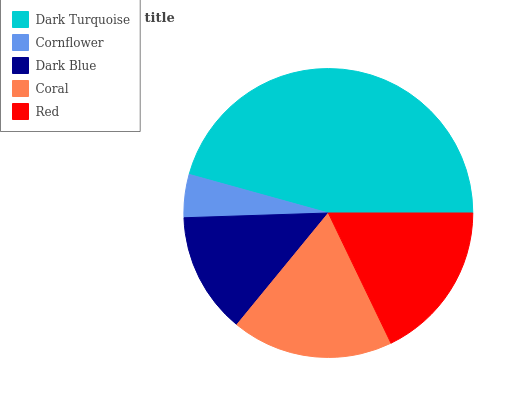Is Cornflower the minimum?
Answer yes or no. Yes. Is Dark Turquoise the maximum?
Answer yes or no. Yes. Is Dark Blue the minimum?
Answer yes or no. No. Is Dark Blue the maximum?
Answer yes or no. No. Is Dark Blue greater than Cornflower?
Answer yes or no. Yes. Is Cornflower less than Dark Blue?
Answer yes or no. Yes. Is Cornflower greater than Dark Blue?
Answer yes or no. No. Is Dark Blue less than Cornflower?
Answer yes or no. No. Is Red the high median?
Answer yes or no. Yes. Is Red the low median?
Answer yes or no. Yes. Is Dark Blue the high median?
Answer yes or no. No. Is Dark Blue the low median?
Answer yes or no. No. 